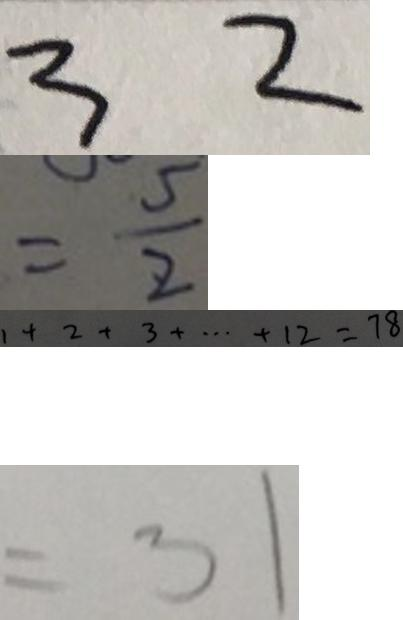<formula> <loc_0><loc_0><loc_500><loc_500>3 2 
 = \frac { 5 } { 2 } 
 1 + 2 + 3 + \cdots + 1 2 = 7 8 
 = 3 1</formula> 